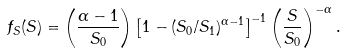<formula> <loc_0><loc_0><loc_500><loc_500>f _ { S } ( S ) = \left ( \frac { \alpha - 1 } { S _ { 0 } } \right ) \left [ 1 - ( S _ { 0 } / S _ { 1 } ) ^ { \alpha - 1 } \right ] ^ { - 1 } \left ( \frac { S } { S _ { 0 } } \right ) ^ { - \alpha } .</formula> 